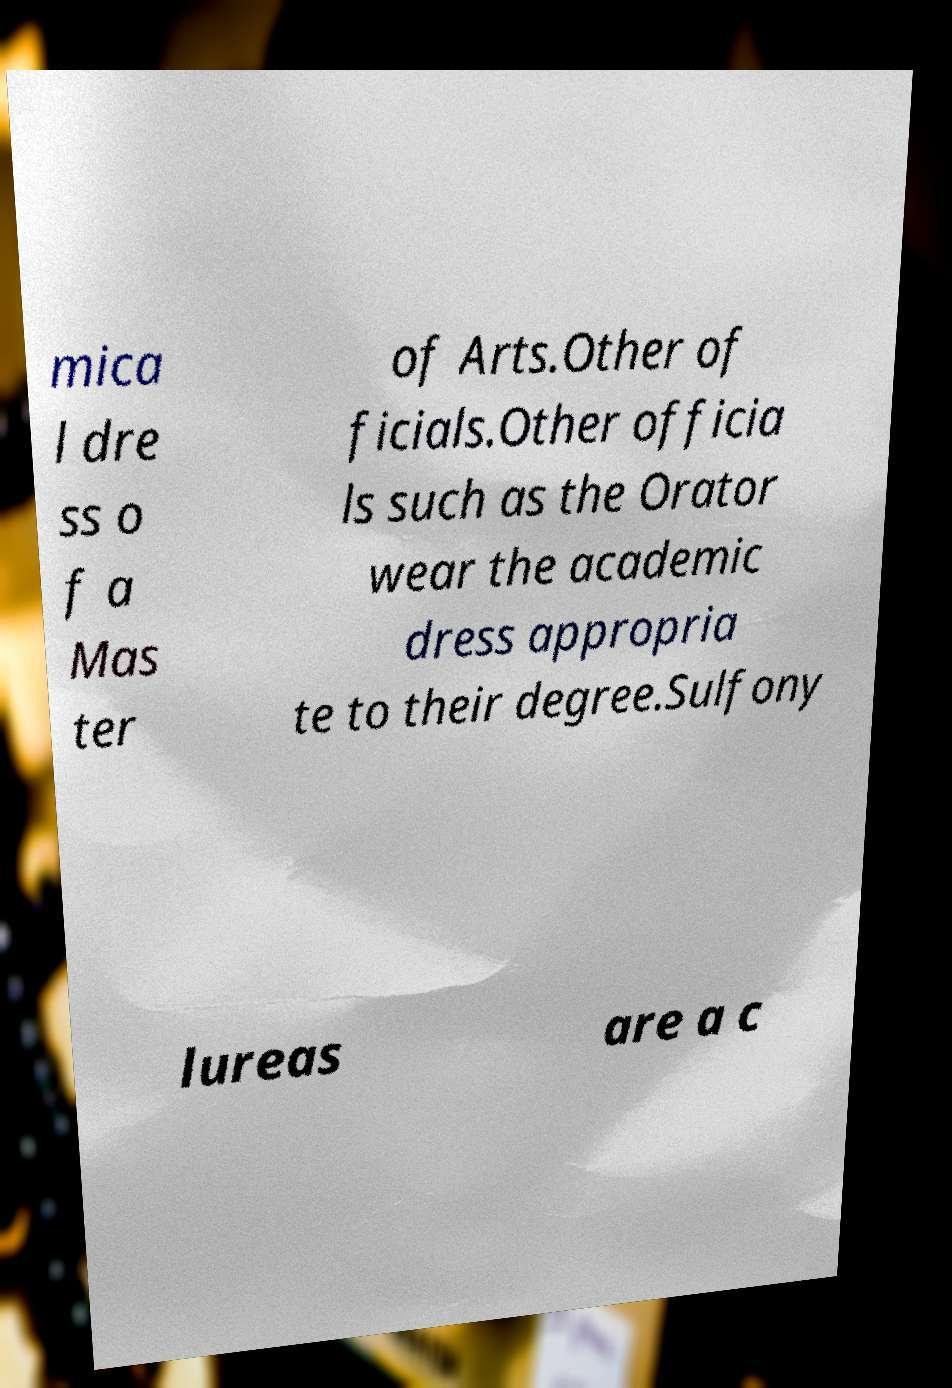Can you accurately transcribe the text from the provided image for me? mica l dre ss o f a Mas ter of Arts.Other of ficials.Other officia ls such as the Orator wear the academic dress appropria te to their degree.Sulfony lureas are a c 